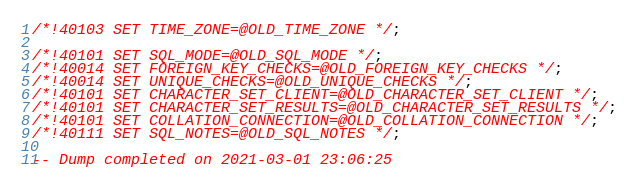<code> <loc_0><loc_0><loc_500><loc_500><_SQL_>/*!40103 SET TIME_ZONE=@OLD_TIME_ZONE */;

/*!40101 SET SQL_MODE=@OLD_SQL_MODE */;
/*!40014 SET FOREIGN_KEY_CHECKS=@OLD_FOREIGN_KEY_CHECKS */;
/*!40014 SET UNIQUE_CHECKS=@OLD_UNIQUE_CHECKS */;
/*!40101 SET CHARACTER_SET_CLIENT=@OLD_CHARACTER_SET_CLIENT */;
/*!40101 SET CHARACTER_SET_RESULTS=@OLD_CHARACTER_SET_RESULTS */;
/*!40101 SET COLLATION_CONNECTION=@OLD_COLLATION_CONNECTION */;
/*!40111 SET SQL_NOTES=@OLD_SQL_NOTES */;

-- Dump completed on 2021-03-01 23:06:25
</code> 